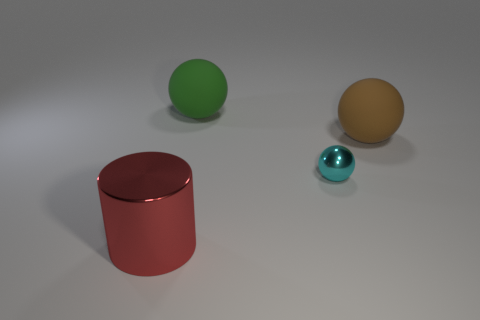Is the tiny cyan thing made of the same material as the red thing? While it's difficult to determine material composition from a visual inspection alone, the tiny cyan object appears to have a similar reflective quality to the surface of the red cylinder, suggesting that it might be made of a similar material, such as painted ceramic or plastic. 